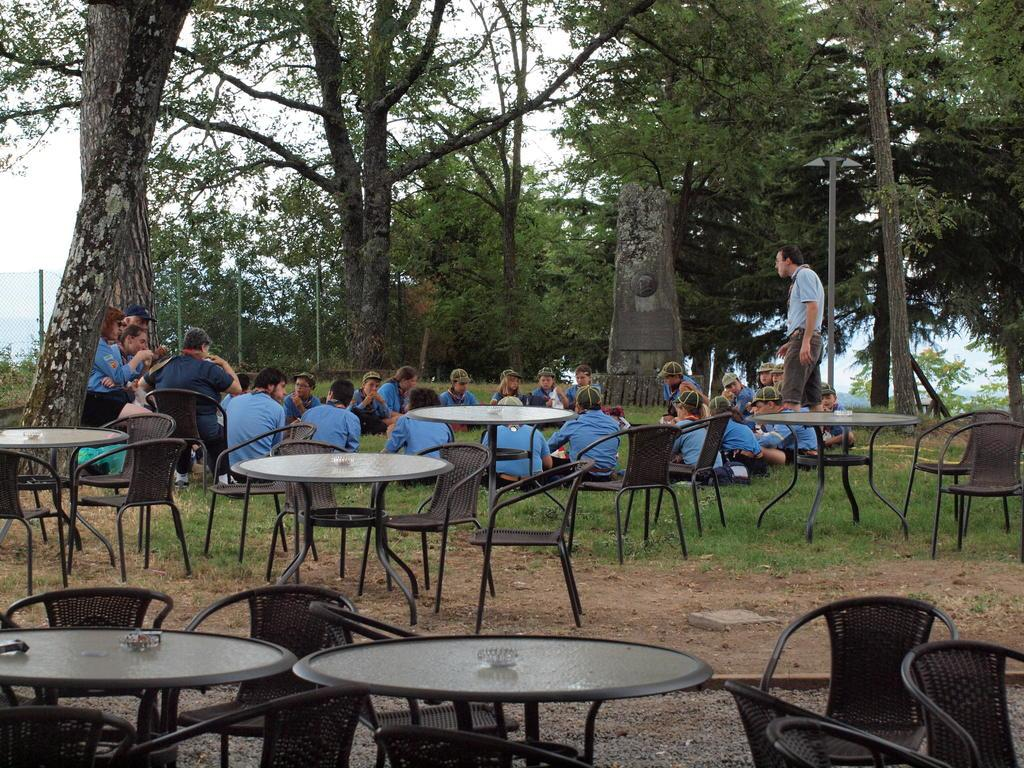What are the persons in the image doing? The persons in the image are sitting on chairs and grass. What type of environment is visible in the image? There are trees visible in the image, suggesting a natural setting. What type of furniture is present in the image? Chairs and tables are present in the image. Are there any standing persons in the image? Yes, there is a person standing in the image. What type of industry is depicted in the image? There is no industry depicted in the image; it features persons sitting on chairs and grass, trees, and furniture. 